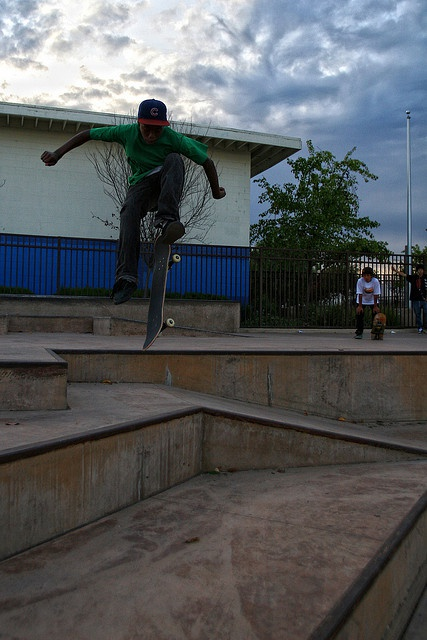Describe the objects in this image and their specific colors. I can see people in darkgray, black, gray, darkgreen, and teal tones, skateboard in darkgray, black, gray, and navy tones, people in darkgray, black, gray, and maroon tones, people in darkgray, black, maroon, and gray tones, and skateboard in darkgray, black, maroon, and gray tones in this image. 